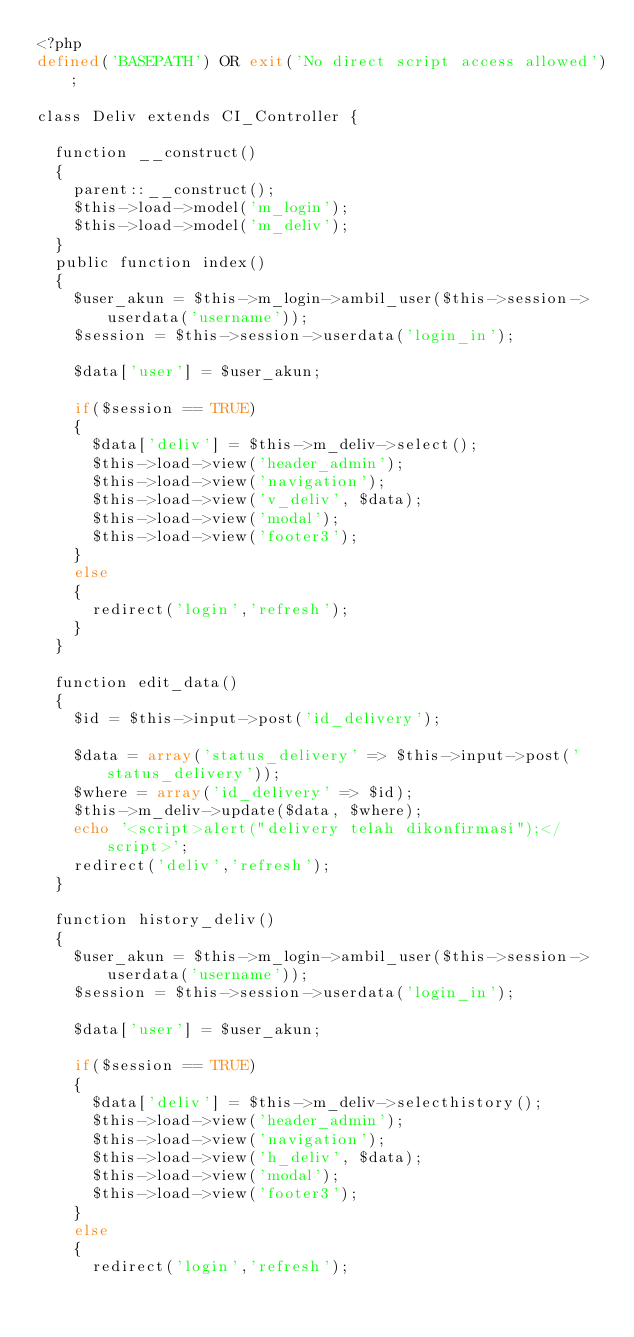<code> <loc_0><loc_0><loc_500><loc_500><_PHP_><?php
defined('BASEPATH') OR exit('No direct script access allowed');

class Deliv extends CI_Controller {

	function __construct()
	{
		parent::__construct();
		$this->load->model('m_login');
		$this->load->model('m_deliv');
	}
	public function index()
	{
		$user_akun = $this->m_login->ambil_user($this->session->userdata('username'));
		$session = $this->session->userdata('login_in');

		$data['user'] = $user_akun;

		if($session == TRUE)
		{
			$data['deliv'] = $this->m_deliv->select();
			$this->load->view('header_admin');
			$this->load->view('navigation');
			$this->load->view('v_deliv', $data);
			$this->load->view('modal');
			$this->load->view('footer3');
		}
		else
		{
			redirect('login','refresh');
		}
	}

	function edit_data()
	{
		$id = $this->input->post('id_delivery');

		$data = array('status_delivery' => $this->input->post('status_delivery'));
		$where = array('id_delivery' => $id);
		$this->m_deliv->update($data, $where);
		echo '<script>alert("delivery telah dikonfirmasi");</script>';
		redirect('deliv','refresh');
	}

	function history_deliv()
	{
		$user_akun = $this->m_login->ambil_user($this->session->userdata('username'));
		$session = $this->session->userdata('login_in');

		$data['user'] = $user_akun;

		if($session == TRUE)
		{
			$data['deliv'] = $this->m_deliv->selecthistory();
			$this->load->view('header_admin');
			$this->load->view('navigation');
			$this->load->view('h_deliv', $data);
			$this->load->view('modal');
			$this->load->view('footer3');
		}
		else
		{
			redirect('login','refresh');</code> 